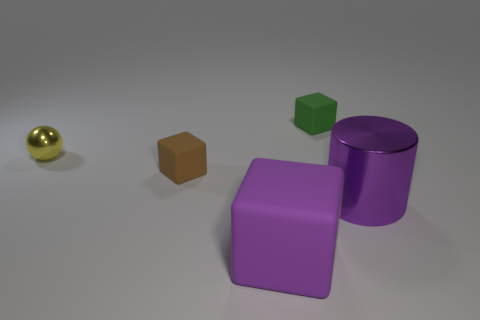Subtract all small green rubber cubes. How many cubes are left? 2 Add 2 yellow metal balls. How many objects exist? 7 Subtract 1 blocks. How many blocks are left? 2 Subtract all cylinders. How many objects are left? 4 Subtract all purple shiny cylinders. Subtract all rubber cubes. How many objects are left? 1 Add 4 small shiny things. How many small shiny things are left? 5 Add 5 purple rubber things. How many purple rubber things exist? 6 Subtract 0 blue balls. How many objects are left? 5 Subtract all gray blocks. Subtract all brown cylinders. How many blocks are left? 3 